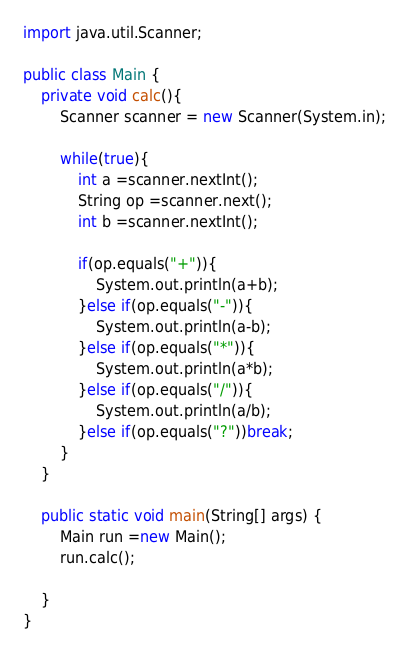<code> <loc_0><loc_0><loc_500><loc_500><_Java_>import java.util.Scanner;

public class Main {
	private void calc(){
		Scanner scanner = new Scanner(System.in);
		
		while(true){
			int a =scanner.nextInt();
			String op =scanner.next();
			int b =scanner.nextInt();
			
			if(op.equals("+")){
				System.out.println(a+b);
			}else if(op.equals("-")){
				System.out.println(a-b);
			}else if(op.equals("*")){
				System.out.println(a*b);
			}else if(op.equals("/")){
				System.out.println(a/b);
			}else if(op.equals("?"))break; 
		}
	}
	
	public static void main(String[] args) {
		Main run =new Main();
		run.calc();

	}
}</code> 